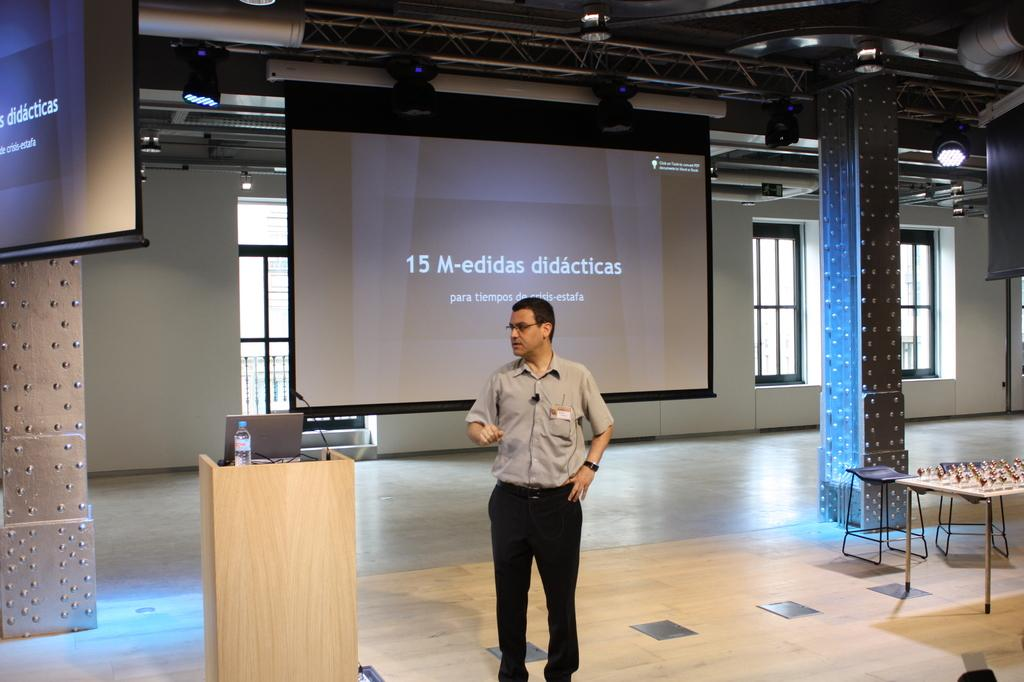<image>
Describe the image concisely. A man standing near a podium with a slide behind him titled 15 M-edidas didacticas. 